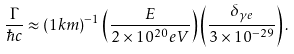Convert formula to latex. <formula><loc_0><loc_0><loc_500><loc_500>\frac { \Gamma } { \hbar { c } } \approx ( 1 k m ) ^ { - 1 } \left ( \frac { E } { 2 \times 1 0 ^ { 2 0 } e V } \right ) \left ( \frac { \delta _ { \gamma e } } { 3 \times 1 0 ^ { - 2 9 } } \right ) .</formula> 